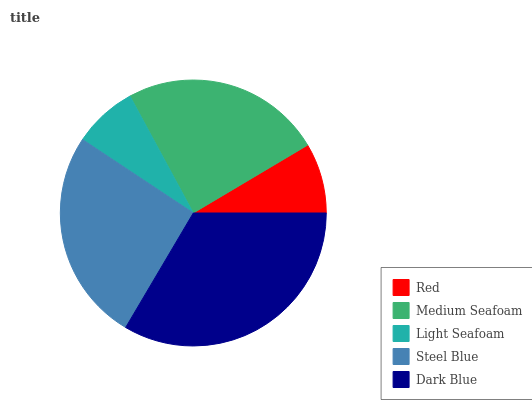Is Light Seafoam the minimum?
Answer yes or no. Yes. Is Dark Blue the maximum?
Answer yes or no. Yes. Is Medium Seafoam the minimum?
Answer yes or no. No. Is Medium Seafoam the maximum?
Answer yes or no. No. Is Medium Seafoam greater than Red?
Answer yes or no. Yes. Is Red less than Medium Seafoam?
Answer yes or no. Yes. Is Red greater than Medium Seafoam?
Answer yes or no. No. Is Medium Seafoam less than Red?
Answer yes or no. No. Is Medium Seafoam the high median?
Answer yes or no. Yes. Is Medium Seafoam the low median?
Answer yes or no. Yes. Is Red the high median?
Answer yes or no. No. Is Steel Blue the low median?
Answer yes or no. No. 